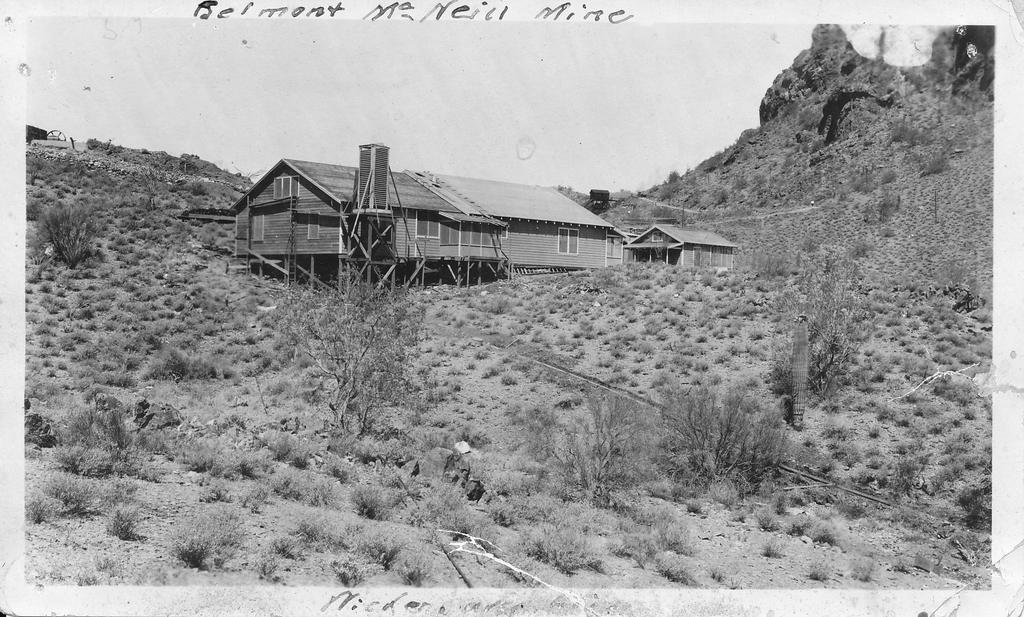Please provide a concise description of this image. This image looks like a photo in which I can see grass, plants, trees, houses, mountains, text and the sky. 